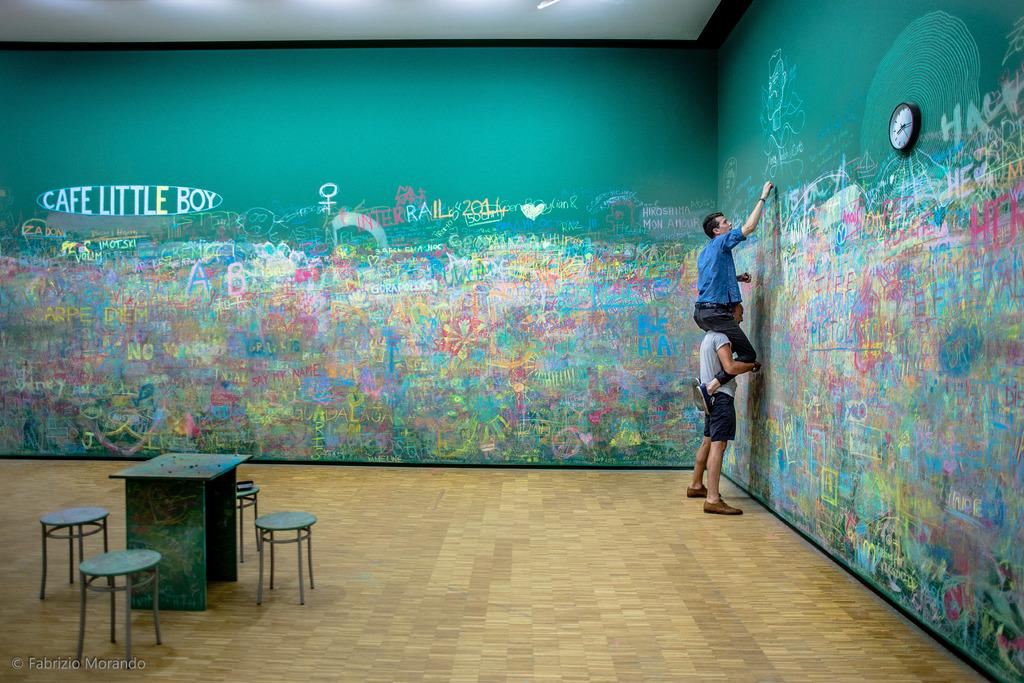What is the position of the first man in the image? There is a man standing in the image. What is the second man doing in the image? There is a man sitting on the standing man's shoulder. What activity is the sitting man engaged in? The sitting man is writing on a wall. What type of furniture can be seen in the background of the image? There is a table and benches on the floor in the background of the image. What type of grape is the standing man eating in the image? There is no grape present in the image, and the standing man is not eating anything. What is the sitting man reading in the image? There is no reading material present in the image, and the sitting man is writing on a wall. 